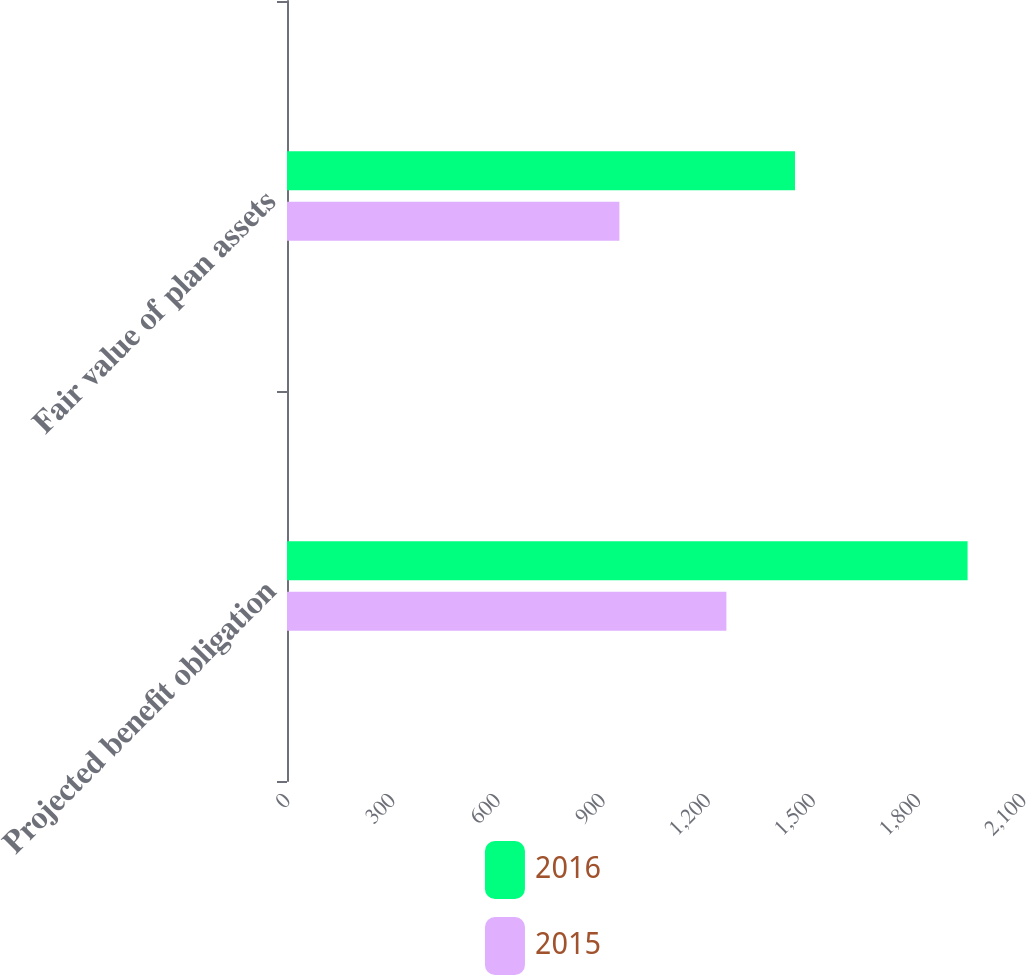<chart> <loc_0><loc_0><loc_500><loc_500><stacked_bar_chart><ecel><fcel>Projected benefit obligation<fcel>Fair value of plan assets<nl><fcel>2016<fcel>1941.9<fcel>1449.5<nl><fcel>2015<fcel>1253.7<fcel>948.4<nl></chart> 